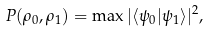<formula> <loc_0><loc_0><loc_500><loc_500>P ( \rho _ { 0 } , \rho _ { 1 } ) = \max | \langle \psi _ { 0 } | \psi _ { 1 } \rangle | ^ { 2 } ,</formula> 